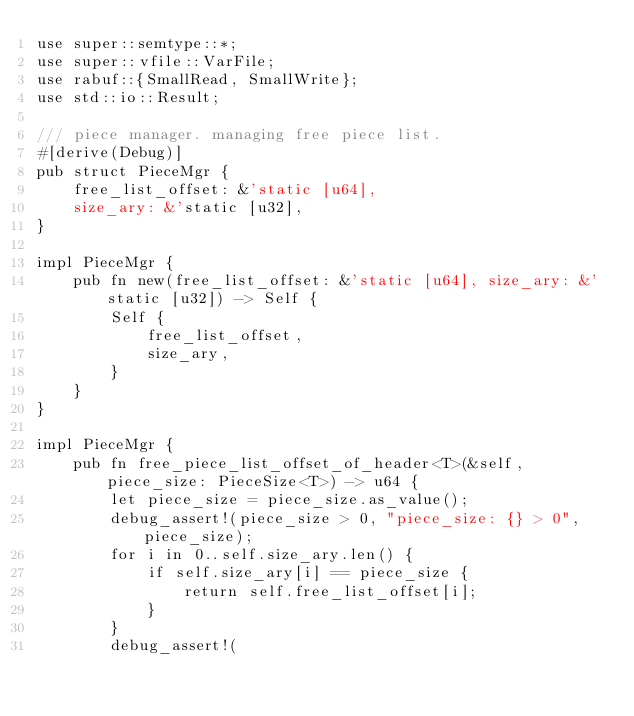Convert code to text. <code><loc_0><loc_0><loc_500><loc_500><_Rust_>use super::semtype::*;
use super::vfile::VarFile;
use rabuf::{SmallRead, SmallWrite};
use std::io::Result;

/// piece manager. managing free piece list.
#[derive(Debug)]
pub struct PieceMgr {
    free_list_offset: &'static [u64],
    size_ary: &'static [u32],
}

impl PieceMgr {
    pub fn new(free_list_offset: &'static [u64], size_ary: &'static [u32]) -> Self {
        Self {
            free_list_offset,
            size_ary,
        }
    }
}

impl PieceMgr {
    pub fn free_piece_list_offset_of_header<T>(&self, piece_size: PieceSize<T>) -> u64 {
        let piece_size = piece_size.as_value();
        debug_assert!(piece_size > 0, "piece_size: {} > 0", piece_size);
        for i in 0..self.size_ary.len() {
            if self.size_ary[i] == piece_size {
                return self.free_list_offset[i];
            }
        }
        debug_assert!(</code> 